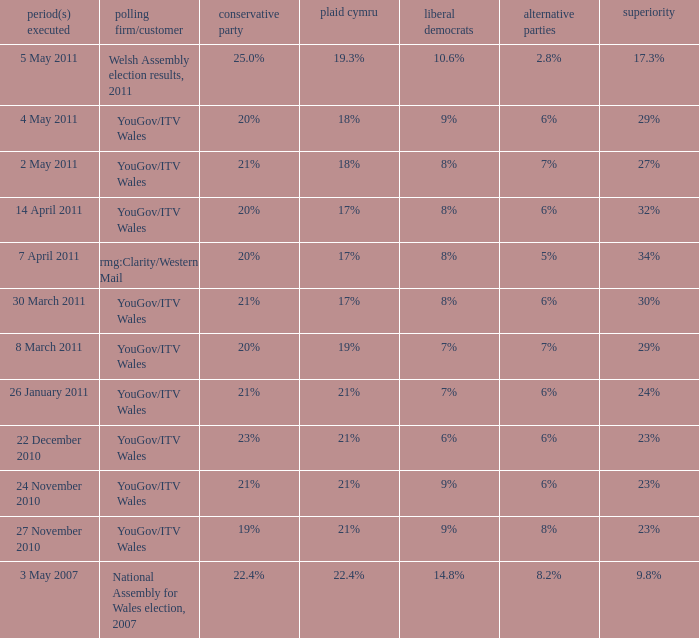I want the plaid cymru for 4 may 2011 18%. 